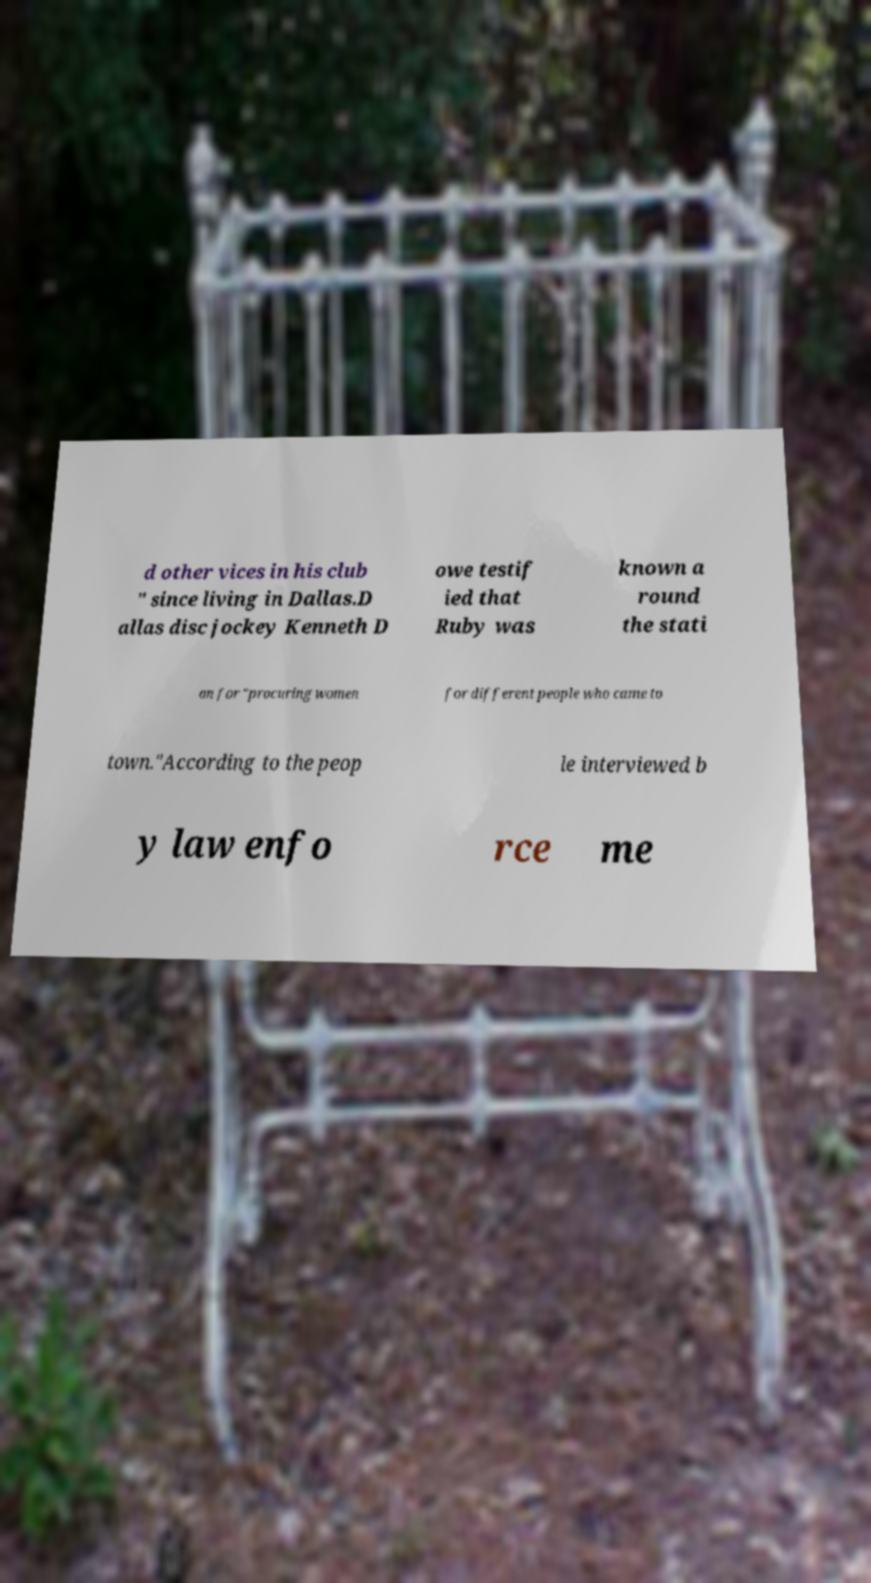I need the written content from this picture converted into text. Can you do that? d other vices in his club " since living in Dallas.D allas disc jockey Kenneth D owe testif ied that Ruby was known a round the stati on for "procuring women for different people who came to town."According to the peop le interviewed b y law enfo rce me 